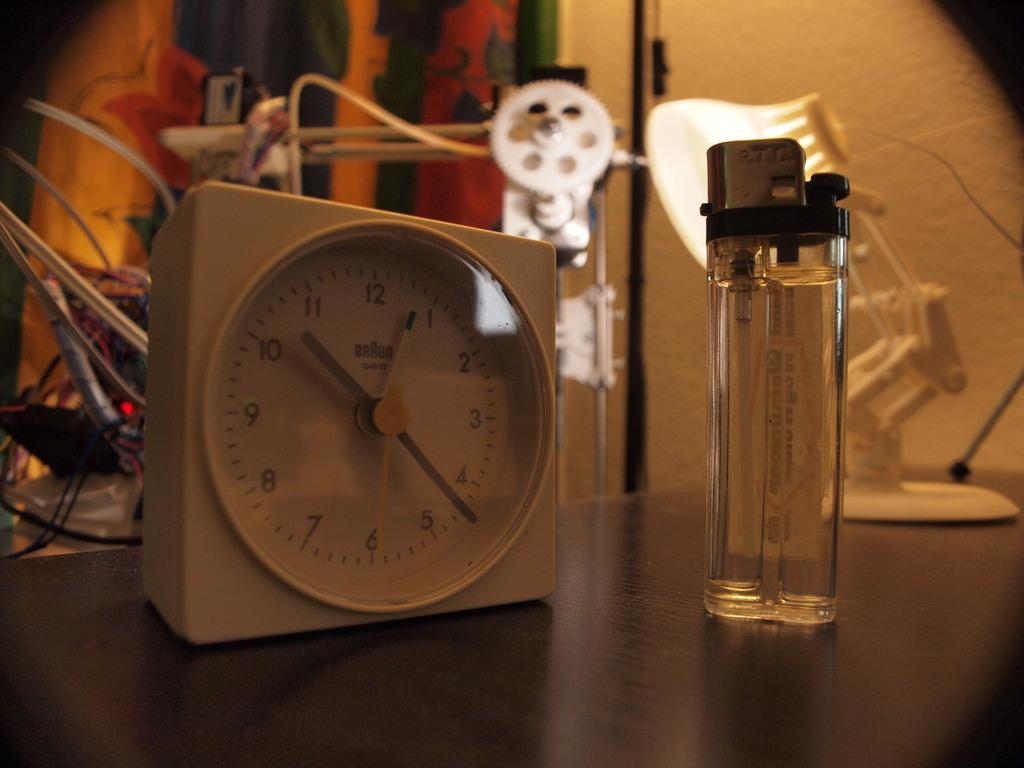What type of object can be seen in the image that displays time? There is a clock in the image. What object in the image can be used to create fire? There is a lighter in the image. What type of light source is present in the image? There is a light on a stand in the image. Where are the objects located in the image? The objects are on a platform. What can be seen in the background of the image? There are cables, a device, other objects, and a wall in the background of the image. How many snails are crawling on the wall in the image? There are no snails present in the image; the wall in the background does not show any snails. 